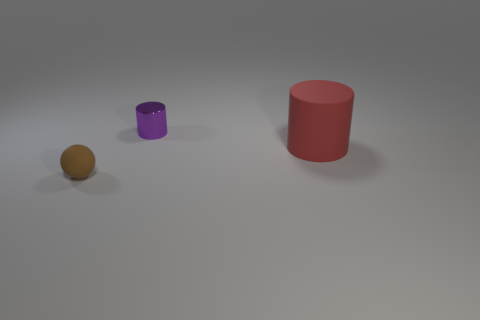Add 1 rubber cylinders. How many objects exist? 4 Subtract all red cylinders. How many cylinders are left? 1 Subtract all cylinders. How many objects are left? 1 Subtract 1 cylinders. How many cylinders are left? 1 Subtract all purple balls. Subtract all blue cylinders. How many balls are left? 1 Subtract all brown balls. How many purple cylinders are left? 1 Subtract all purple shiny objects. Subtract all matte spheres. How many objects are left? 1 Add 3 tiny brown spheres. How many tiny brown spheres are left? 4 Add 2 large red things. How many large red things exist? 3 Subtract 0 gray spheres. How many objects are left? 3 